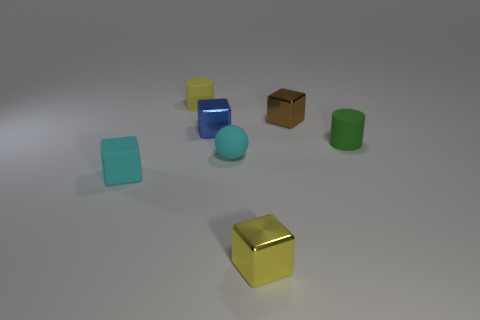There is a small thing that is to the right of the shiny block that is right of the tiny yellow metallic cube; what number of small cylinders are behind it?
Provide a short and direct response. 1. What shape is the tiny matte object that is on the right side of the yellow object that is in front of the small shiny object to the left of the cyan ball?
Offer a terse response. Cylinder. How many other objects are there of the same color as the matte block?
Your answer should be compact. 1. What shape is the metallic object that is on the left side of the tiny thing in front of the small rubber cube?
Ensure brevity in your answer.  Cube. How many tiny cyan rubber blocks are to the right of the small rubber ball?
Make the answer very short. 0. Are there any small brown things that have the same material as the small yellow block?
Provide a short and direct response. Yes. There is a brown cube that is the same size as the green matte thing; what is its material?
Give a very brief answer. Metal. There is a metallic object that is both in front of the tiny brown shiny thing and behind the rubber cube; what color is it?
Give a very brief answer. Blue. Are there fewer small metallic cubes that are on the left side of the blue metal cube than blocks to the left of the sphere?
Ensure brevity in your answer.  Yes. What number of other small brown objects have the same shape as the small brown metal thing?
Give a very brief answer. 0. 